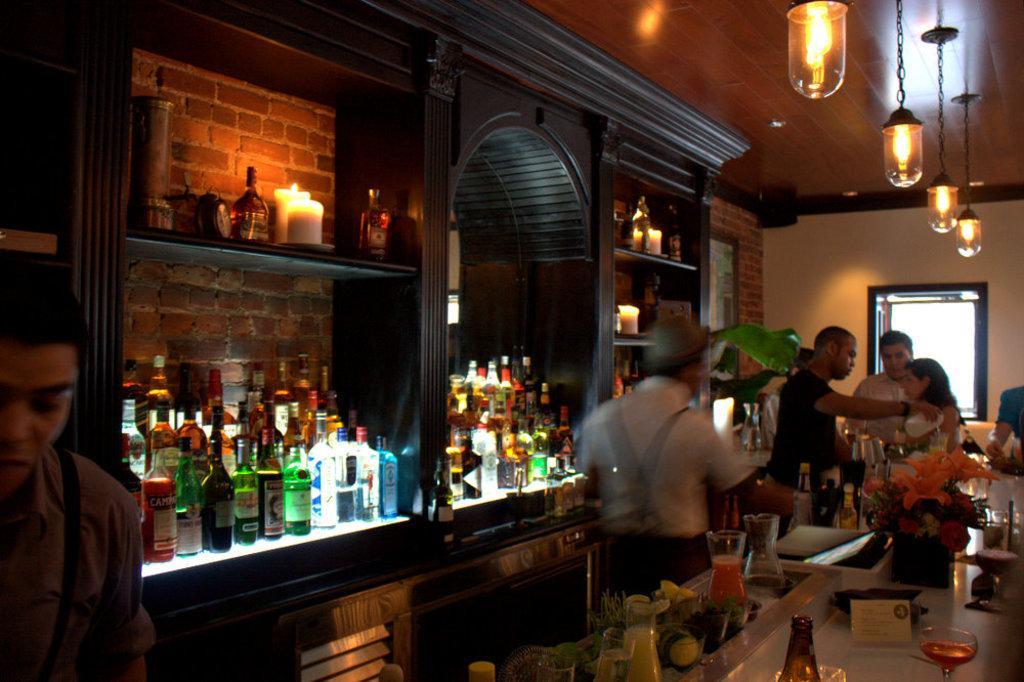How would you summarize this image in a sentence or two? At the top we can see ceiling and lights. Here we can see candles and bottles in the racks. Here on the platform we can see glasses, bottles and other objects. This is a wall with bricks. 